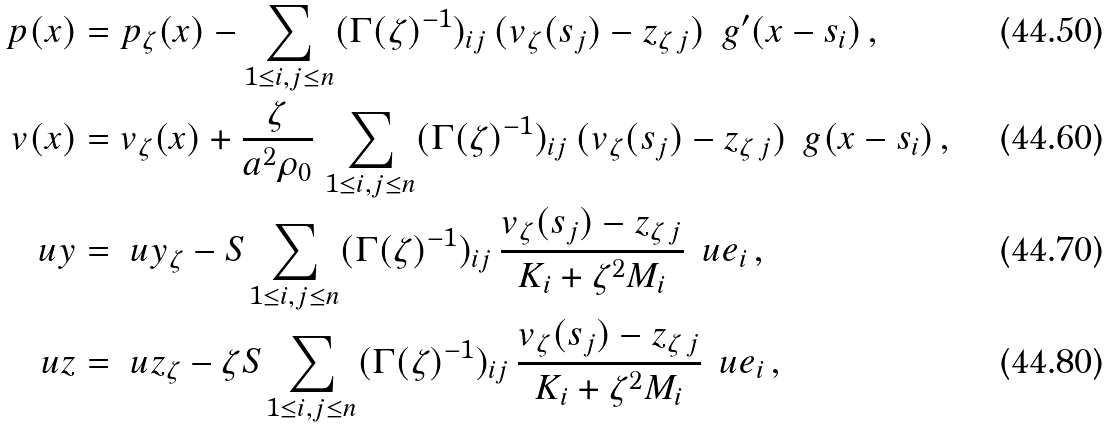Convert formula to latex. <formula><loc_0><loc_0><loc_500><loc_500>p ( x ) & = p _ { \zeta } ( x ) - \sum _ { 1 \leq i , j \leq n } ( \Gamma ( \zeta ) ^ { - 1 } ) _ { i j } \, ( v _ { \zeta } ( s _ { j } ) - z _ { \zeta \, j } ) \, \ g ^ { \prime } ( x - s _ { i } ) \, , \\ v ( x ) & = v _ { \zeta } ( x ) + \frac { \zeta } { a ^ { 2 } \rho _ { 0 } } \, \sum _ { 1 \leq i , j \leq n } ( \Gamma ( \zeta ) ^ { - 1 } ) _ { i j } \, ( v _ { \zeta } ( s _ { j } ) - z _ { \zeta \, j } ) \, \ g ( x - s _ { i } ) \, , \\ \ u y & = \ u y _ { \zeta } - S \sum _ { 1 \leq i , j \leq n } ( \Gamma ( \zeta ) ^ { - 1 } ) _ { i j } \, \frac { v _ { \zeta } ( s _ { j } ) - z _ { \zeta \, j } } { K _ { i } + \zeta ^ { 2 } M _ { i } } \, \ u e _ { i } \, , \\ \ u z & = \ u z _ { \zeta } - \zeta S \sum _ { 1 \leq i , j \leq n } ( \Gamma ( \zeta ) ^ { - 1 } ) _ { i j } \, \frac { v _ { \zeta } ( s _ { j } ) - z _ { \zeta \, j } } { K _ { i } + \zeta ^ { 2 } M _ { i } } \, \ u e _ { i } \, ,</formula> 